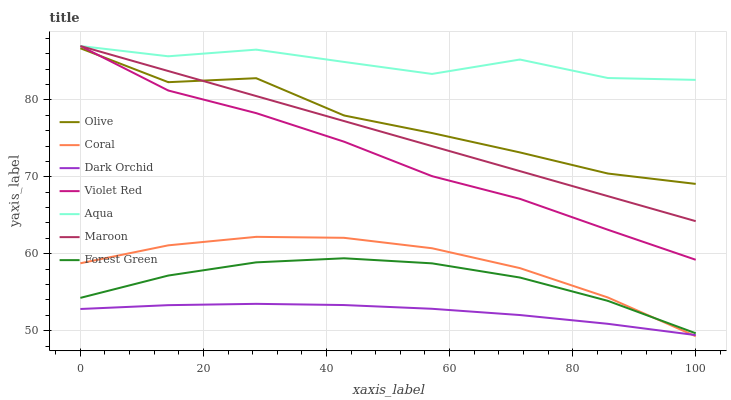Does Dark Orchid have the minimum area under the curve?
Answer yes or no. Yes. Does Aqua have the maximum area under the curve?
Answer yes or no. Yes. Does Coral have the minimum area under the curve?
Answer yes or no. No. Does Coral have the maximum area under the curve?
Answer yes or no. No. Is Maroon the smoothest?
Answer yes or no. Yes. Is Olive the roughest?
Answer yes or no. Yes. Is Coral the smoothest?
Answer yes or no. No. Is Coral the roughest?
Answer yes or no. No. Does Coral have the lowest value?
Answer yes or no. Yes. Does Aqua have the lowest value?
Answer yes or no. No. Does Maroon have the highest value?
Answer yes or no. Yes. Does Coral have the highest value?
Answer yes or no. No. Is Forest Green less than Olive?
Answer yes or no. Yes. Is Violet Red greater than Dark Orchid?
Answer yes or no. Yes. Does Olive intersect Maroon?
Answer yes or no. Yes. Is Olive less than Maroon?
Answer yes or no. No. Is Olive greater than Maroon?
Answer yes or no. No. Does Forest Green intersect Olive?
Answer yes or no. No. 